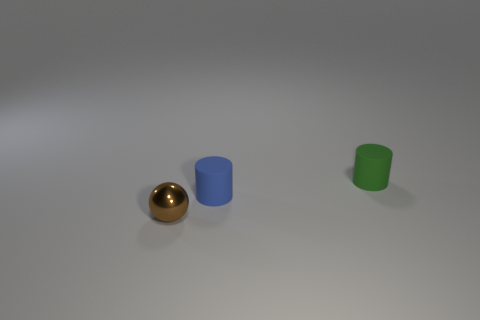Add 2 tiny green matte things. How many objects exist? 5 Subtract all cylinders. How many objects are left? 1 Subtract all shiny spheres. Subtract all brown objects. How many objects are left? 1 Add 2 metallic things. How many metallic things are left? 3 Add 1 tiny objects. How many tiny objects exist? 4 Subtract 1 blue cylinders. How many objects are left? 2 